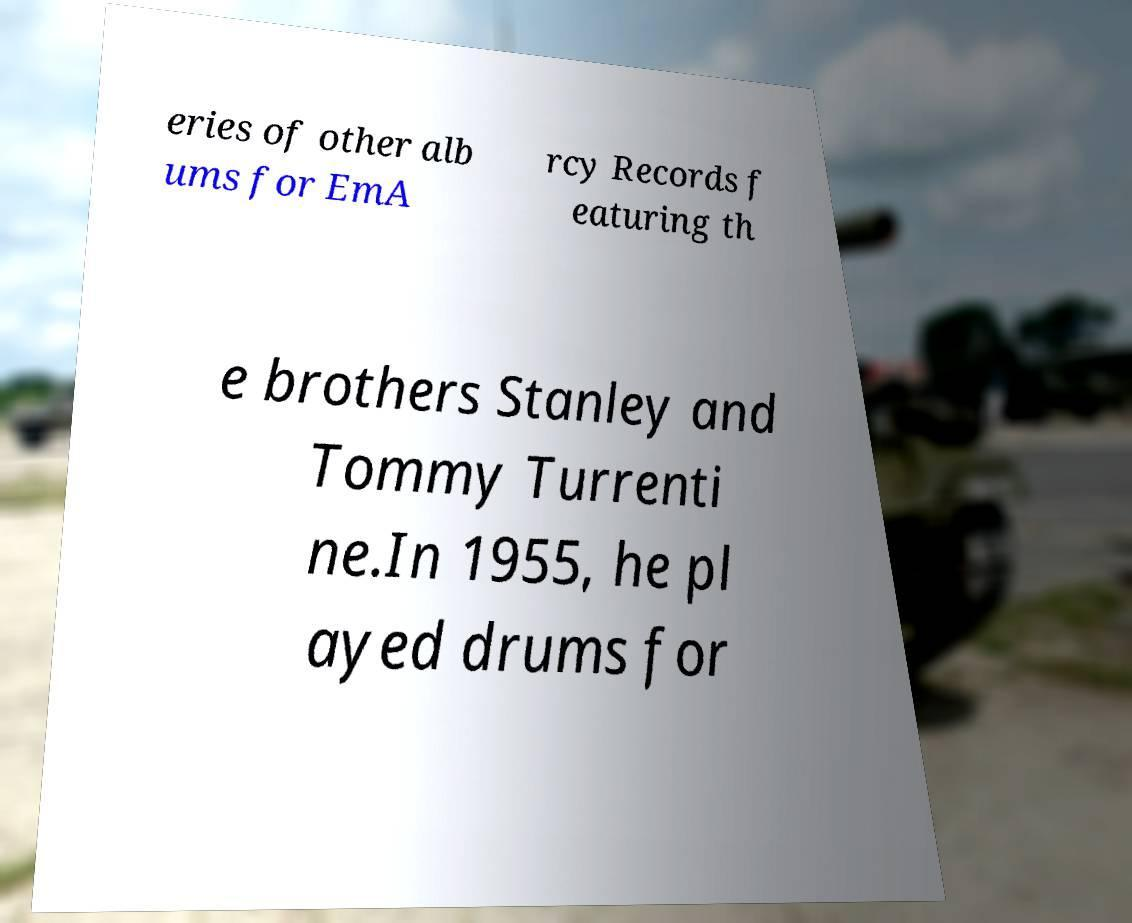Could you extract and type out the text from this image? eries of other alb ums for EmA rcy Records f eaturing th e brothers Stanley and Tommy Turrenti ne.In 1955, he pl ayed drums for 